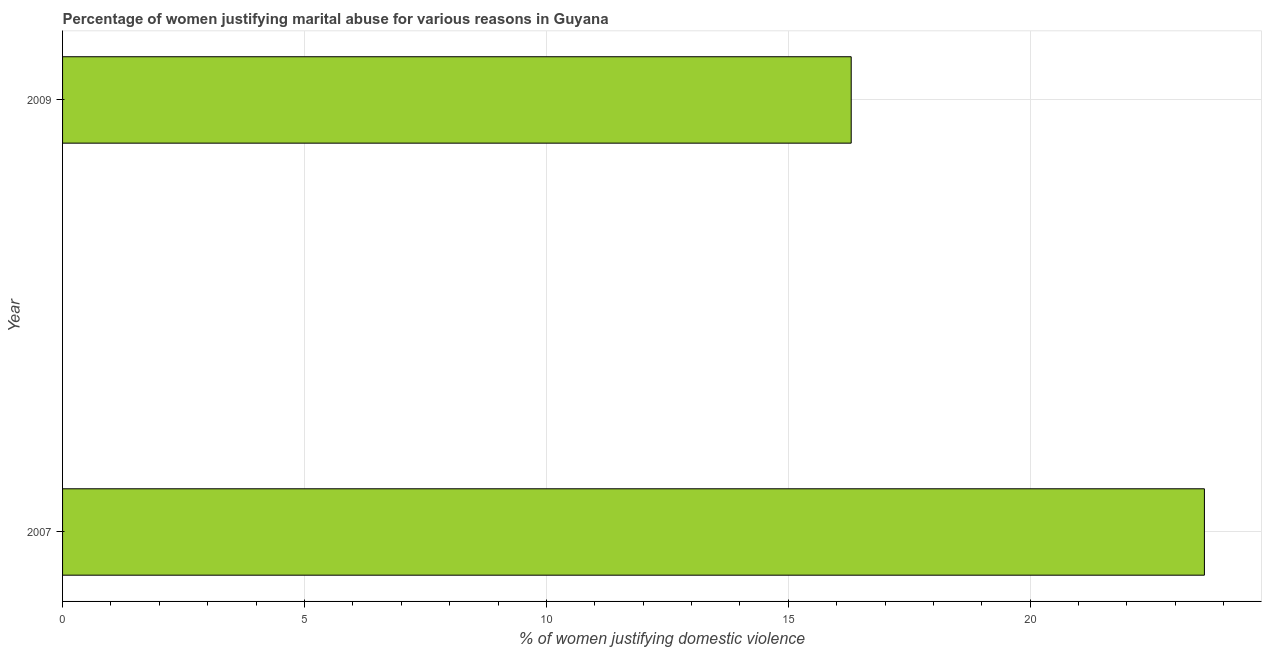Does the graph contain any zero values?
Give a very brief answer. No. Does the graph contain grids?
Make the answer very short. Yes. What is the title of the graph?
Your response must be concise. Percentage of women justifying marital abuse for various reasons in Guyana. What is the label or title of the X-axis?
Ensure brevity in your answer.  % of women justifying domestic violence. What is the label or title of the Y-axis?
Your answer should be compact. Year. What is the percentage of women justifying marital abuse in 2009?
Your answer should be compact. 16.3. Across all years, what is the maximum percentage of women justifying marital abuse?
Provide a succinct answer. 23.6. Across all years, what is the minimum percentage of women justifying marital abuse?
Ensure brevity in your answer.  16.3. In which year was the percentage of women justifying marital abuse maximum?
Your answer should be very brief. 2007. In which year was the percentage of women justifying marital abuse minimum?
Make the answer very short. 2009. What is the sum of the percentage of women justifying marital abuse?
Your answer should be compact. 39.9. What is the difference between the percentage of women justifying marital abuse in 2007 and 2009?
Ensure brevity in your answer.  7.3. What is the average percentage of women justifying marital abuse per year?
Make the answer very short. 19.95. What is the median percentage of women justifying marital abuse?
Make the answer very short. 19.95. Do a majority of the years between 2009 and 2007 (inclusive) have percentage of women justifying marital abuse greater than 12 %?
Your response must be concise. No. What is the ratio of the percentage of women justifying marital abuse in 2007 to that in 2009?
Your answer should be compact. 1.45. Is the percentage of women justifying marital abuse in 2007 less than that in 2009?
Offer a very short reply. No. How many years are there in the graph?
Offer a very short reply. 2. Are the values on the major ticks of X-axis written in scientific E-notation?
Your answer should be very brief. No. What is the % of women justifying domestic violence in 2007?
Provide a succinct answer. 23.6. What is the difference between the % of women justifying domestic violence in 2007 and 2009?
Keep it short and to the point. 7.3. What is the ratio of the % of women justifying domestic violence in 2007 to that in 2009?
Provide a succinct answer. 1.45. 